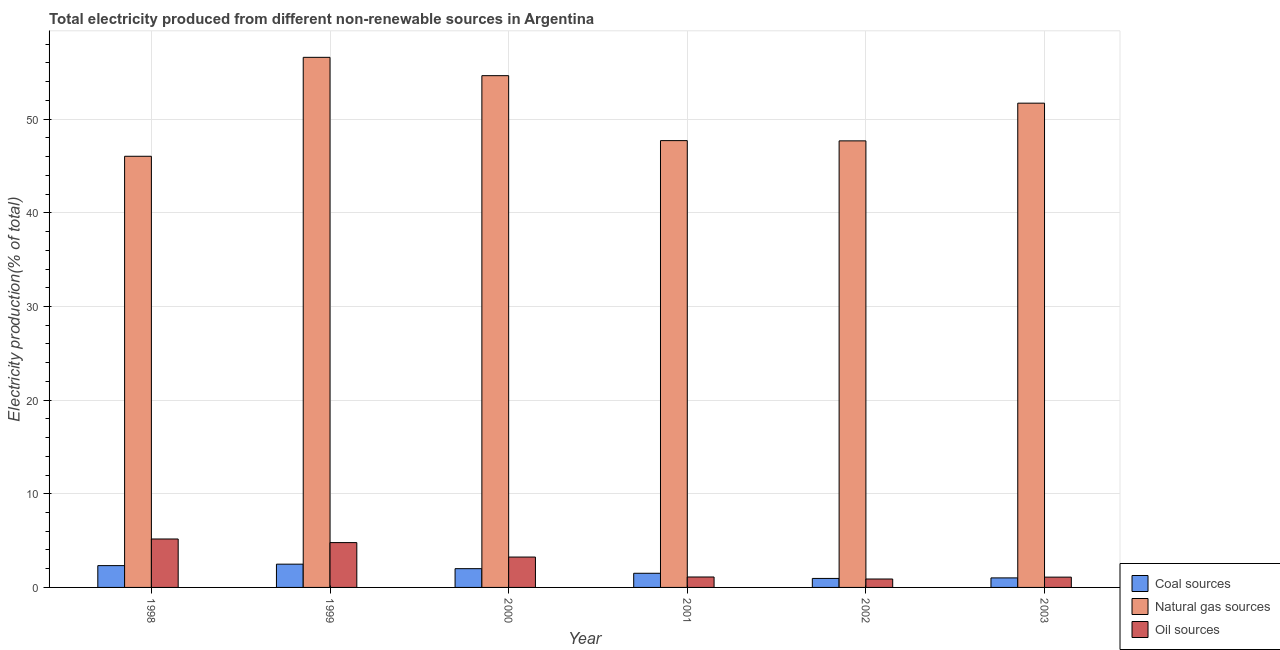Are the number of bars on each tick of the X-axis equal?
Offer a very short reply. Yes. How many bars are there on the 4th tick from the right?
Provide a short and direct response. 3. What is the label of the 2nd group of bars from the left?
Provide a succinct answer. 1999. What is the percentage of electricity produced by oil sources in 2001?
Offer a very short reply. 1.11. Across all years, what is the maximum percentage of electricity produced by coal?
Keep it short and to the point. 2.48. Across all years, what is the minimum percentage of electricity produced by natural gas?
Keep it short and to the point. 46.04. In which year was the percentage of electricity produced by coal maximum?
Your response must be concise. 1999. What is the total percentage of electricity produced by natural gas in the graph?
Offer a terse response. 304.4. What is the difference between the percentage of electricity produced by oil sources in 1999 and that in 2003?
Give a very brief answer. 3.69. What is the difference between the percentage of electricity produced by coal in 2003 and the percentage of electricity produced by natural gas in 1998?
Your response must be concise. -1.31. What is the average percentage of electricity produced by coal per year?
Your answer should be very brief. 1.72. What is the ratio of the percentage of electricity produced by natural gas in 2000 to that in 2002?
Your answer should be compact. 1.15. Is the percentage of electricity produced by coal in 1998 less than that in 2000?
Provide a short and direct response. No. Is the difference between the percentage of electricity produced by oil sources in 2000 and 2003 greater than the difference between the percentage of electricity produced by coal in 2000 and 2003?
Your answer should be very brief. No. What is the difference between the highest and the second highest percentage of electricity produced by oil sources?
Provide a succinct answer. 0.39. What is the difference between the highest and the lowest percentage of electricity produced by oil sources?
Your answer should be compact. 4.27. What does the 2nd bar from the left in 2001 represents?
Give a very brief answer. Natural gas sources. What does the 3rd bar from the right in 2003 represents?
Make the answer very short. Coal sources. How many bars are there?
Give a very brief answer. 18. Are all the bars in the graph horizontal?
Your answer should be compact. No. What is the difference between two consecutive major ticks on the Y-axis?
Offer a terse response. 10. Where does the legend appear in the graph?
Make the answer very short. Bottom right. What is the title of the graph?
Make the answer very short. Total electricity produced from different non-renewable sources in Argentina. What is the Electricity production(% of total) in Coal sources in 1998?
Your response must be concise. 2.33. What is the Electricity production(% of total) in Natural gas sources in 1998?
Give a very brief answer. 46.04. What is the Electricity production(% of total) in Oil sources in 1998?
Make the answer very short. 5.17. What is the Electricity production(% of total) in Coal sources in 1999?
Your answer should be very brief. 2.48. What is the Electricity production(% of total) in Natural gas sources in 1999?
Make the answer very short. 56.6. What is the Electricity production(% of total) in Oil sources in 1999?
Give a very brief answer. 4.79. What is the Electricity production(% of total) in Coal sources in 2000?
Offer a terse response. 2. What is the Electricity production(% of total) of Natural gas sources in 2000?
Your response must be concise. 54.65. What is the Electricity production(% of total) of Oil sources in 2000?
Keep it short and to the point. 3.24. What is the Electricity production(% of total) of Coal sources in 2001?
Ensure brevity in your answer.  1.51. What is the Electricity production(% of total) of Natural gas sources in 2001?
Your answer should be very brief. 47.71. What is the Electricity production(% of total) of Oil sources in 2001?
Offer a terse response. 1.11. What is the Electricity production(% of total) in Coal sources in 2002?
Offer a very short reply. 0.96. What is the Electricity production(% of total) of Natural gas sources in 2002?
Provide a succinct answer. 47.68. What is the Electricity production(% of total) in Oil sources in 2002?
Provide a succinct answer. 0.9. What is the Electricity production(% of total) in Coal sources in 2003?
Make the answer very short. 1.02. What is the Electricity production(% of total) of Natural gas sources in 2003?
Offer a terse response. 51.71. What is the Electricity production(% of total) in Oil sources in 2003?
Provide a short and direct response. 1.1. Across all years, what is the maximum Electricity production(% of total) in Coal sources?
Make the answer very short. 2.48. Across all years, what is the maximum Electricity production(% of total) in Natural gas sources?
Your answer should be very brief. 56.6. Across all years, what is the maximum Electricity production(% of total) of Oil sources?
Make the answer very short. 5.17. Across all years, what is the minimum Electricity production(% of total) of Coal sources?
Your response must be concise. 0.96. Across all years, what is the minimum Electricity production(% of total) of Natural gas sources?
Ensure brevity in your answer.  46.04. Across all years, what is the minimum Electricity production(% of total) of Oil sources?
Provide a short and direct response. 0.9. What is the total Electricity production(% of total) of Coal sources in the graph?
Your response must be concise. 10.31. What is the total Electricity production(% of total) of Natural gas sources in the graph?
Your answer should be very brief. 304.4. What is the total Electricity production(% of total) of Oil sources in the graph?
Offer a terse response. 16.31. What is the difference between the Electricity production(% of total) in Coal sources in 1998 and that in 1999?
Give a very brief answer. -0.16. What is the difference between the Electricity production(% of total) of Natural gas sources in 1998 and that in 1999?
Offer a very short reply. -10.56. What is the difference between the Electricity production(% of total) of Oil sources in 1998 and that in 1999?
Offer a very short reply. 0.39. What is the difference between the Electricity production(% of total) in Coal sources in 1998 and that in 2000?
Give a very brief answer. 0.32. What is the difference between the Electricity production(% of total) of Natural gas sources in 1998 and that in 2000?
Keep it short and to the point. -8.61. What is the difference between the Electricity production(% of total) of Oil sources in 1998 and that in 2000?
Make the answer very short. 1.93. What is the difference between the Electricity production(% of total) of Coal sources in 1998 and that in 2001?
Keep it short and to the point. 0.82. What is the difference between the Electricity production(% of total) in Natural gas sources in 1998 and that in 2001?
Keep it short and to the point. -1.67. What is the difference between the Electricity production(% of total) in Oil sources in 1998 and that in 2001?
Provide a short and direct response. 4.06. What is the difference between the Electricity production(% of total) in Coal sources in 1998 and that in 2002?
Make the answer very short. 1.37. What is the difference between the Electricity production(% of total) of Natural gas sources in 1998 and that in 2002?
Provide a short and direct response. -1.64. What is the difference between the Electricity production(% of total) in Oil sources in 1998 and that in 2002?
Your response must be concise. 4.27. What is the difference between the Electricity production(% of total) in Coal sources in 1998 and that in 2003?
Your answer should be very brief. 1.31. What is the difference between the Electricity production(% of total) of Natural gas sources in 1998 and that in 2003?
Ensure brevity in your answer.  -5.67. What is the difference between the Electricity production(% of total) of Oil sources in 1998 and that in 2003?
Make the answer very short. 4.07. What is the difference between the Electricity production(% of total) of Coal sources in 1999 and that in 2000?
Keep it short and to the point. 0.48. What is the difference between the Electricity production(% of total) of Natural gas sources in 1999 and that in 2000?
Make the answer very short. 1.96. What is the difference between the Electricity production(% of total) of Oil sources in 1999 and that in 2000?
Keep it short and to the point. 1.54. What is the difference between the Electricity production(% of total) in Coal sources in 1999 and that in 2001?
Ensure brevity in your answer.  0.97. What is the difference between the Electricity production(% of total) of Natural gas sources in 1999 and that in 2001?
Offer a terse response. 8.89. What is the difference between the Electricity production(% of total) in Oil sources in 1999 and that in 2001?
Make the answer very short. 3.67. What is the difference between the Electricity production(% of total) in Coal sources in 1999 and that in 2002?
Offer a very short reply. 1.52. What is the difference between the Electricity production(% of total) in Natural gas sources in 1999 and that in 2002?
Keep it short and to the point. 8.92. What is the difference between the Electricity production(% of total) of Oil sources in 1999 and that in 2002?
Your response must be concise. 3.89. What is the difference between the Electricity production(% of total) in Coal sources in 1999 and that in 2003?
Offer a terse response. 1.47. What is the difference between the Electricity production(% of total) in Natural gas sources in 1999 and that in 2003?
Your response must be concise. 4.89. What is the difference between the Electricity production(% of total) of Oil sources in 1999 and that in 2003?
Keep it short and to the point. 3.69. What is the difference between the Electricity production(% of total) in Coal sources in 2000 and that in 2001?
Provide a succinct answer. 0.49. What is the difference between the Electricity production(% of total) in Natural gas sources in 2000 and that in 2001?
Your answer should be compact. 6.94. What is the difference between the Electricity production(% of total) of Oil sources in 2000 and that in 2001?
Offer a terse response. 2.13. What is the difference between the Electricity production(% of total) of Coal sources in 2000 and that in 2002?
Make the answer very short. 1.04. What is the difference between the Electricity production(% of total) of Natural gas sources in 2000 and that in 2002?
Offer a terse response. 6.96. What is the difference between the Electricity production(% of total) in Oil sources in 2000 and that in 2002?
Provide a succinct answer. 2.34. What is the difference between the Electricity production(% of total) of Natural gas sources in 2000 and that in 2003?
Offer a terse response. 2.94. What is the difference between the Electricity production(% of total) in Oil sources in 2000 and that in 2003?
Offer a very short reply. 2.14. What is the difference between the Electricity production(% of total) of Coal sources in 2001 and that in 2002?
Provide a short and direct response. 0.55. What is the difference between the Electricity production(% of total) in Natural gas sources in 2001 and that in 2002?
Provide a succinct answer. 0.03. What is the difference between the Electricity production(% of total) in Oil sources in 2001 and that in 2002?
Keep it short and to the point. 0.22. What is the difference between the Electricity production(% of total) of Coal sources in 2001 and that in 2003?
Provide a succinct answer. 0.49. What is the difference between the Electricity production(% of total) of Natural gas sources in 2001 and that in 2003?
Make the answer very short. -4. What is the difference between the Electricity production(% of total) in Oil sources in 2001 and that in 2003?
Ensure brevity in your answer.  0.02. What is the difference between the Electricity production(% of total) of Coal sources in 2002 and that in 2003?
Ensure brevity in your answer.  -0.06. What is the difference between the Electricity production(% of total) of Natural gas sources in 2002 and that in 2003?
Your answer should be compact. -4.03. What is the difference between the Electricity production(% of total) of Oil sources in 2002 and that in 2003?
Your answer should be very brief. -0.2. What is the difference between the Electricity production(% of total) of Coal sources in 1998 and the Electricity production(% of total) of Natural gas sources in 1999?
Offer a terse response. -54.28. What is the difference between the Electricity production(% of total) in Coal sources in 1998 and the Electricity production(% of total) in Oil sources in 1999?
Ensure brevity in your answer.  -2.46. What is the difference between the Electricity production(% of total) in Natural gas sources in 1998 and the Electricity production(% of total) in Oil sources in 1999?
Provide a succinct answer. 41.25. What is the difference between the Electricity production(% of total) of Coal sources in 1998 and the Electricity production(% of total) of Natural gas sources in 2000?
Ensure brevity in your answer.  -52.32. What is the difference between the Electricity production(% of total) in Coal sources in 1998 and the Electricity production(% of total) in Oil sources in 2000?
Provide a short and direct response. -0.91. What is the difference between the Electricity production(% of total) in Natural gas sources in 1998 and the Electricity production(% of total) in Oil sources in 2000?
Your answer should be very brief. 42.8. What is the difference between the Electricity production(% of total) in Coal sources in 1998 and the Electricity production(% of total) in Natural gas sources in 2001?
Make the answer very short. -45.38. What is the difference between the Electricity production(% of total) of Coal sources in 1998 and the Electricity production(% of total) of Oil sources in 2001?
Your answer should be very brief. 1.21. What is the difference between the Electricity production(% of total) in Natural gas sources in 1998 and the Electricity production(% of total) in Oil sources in 2001?
Provide a succinct answer. 44.93. What is the difference between the Electricity production(% of total) of Coal sources in 1998 and the Electricity production(% of total) of Natural gas sources in 2002?
Offer a terse response. -45.36. What is the difference between the Electricity production(% of total) in Coal sources in 1998 and the Electricity production(% of total) in Oil sources in 2002?
Provide a succinct answer. 1.43. What is the difference between the Electricity production(% of total) of Natural gas sources in 1998 and the Electricity production(% of total) of Oil sources in 2002?
Provide a short and direct response. 45.14. What is the difference between the Electricity production(% of total) in Coal sources in 1998 and the Electricity production(% of total) in Natural gas sources in 2003?
Offer a very short reply. -49.38. What is the difference between the Electricity production(% of total) in Coal sources in 1998 and the Electricity production(% of total) in Oil sources in 2003?
Provide a short and direct response. 1.23. What is the difference between the Electricity production(% of total) in Natural gas sources in 1998 and the Electricity production(% of total) in Oil sources in 2003?
Provide a succinct answer. 44.94. What is the difference between the Electricity production(% of total) of Coal sources in 1999 and the Electricity production(% of total) of Natural gas sources in 2000?
Make the answer very short. -52.16. What is the difference between the Electricity production(% of total) of Coal sources in 1999 and the Electricity production(% of total) of Oil sources in 2000?
Your response must be concise. -0.76. What is the difference between the Electricity production(% of total) in Natural gas sources in 1999 and the Electricity production(% of total) in Oil sources in 2000?
Provide a short and direct response. 53.36. What is the difference between the Electricity production(% of total) in Coal sources in 1999 and the Electricity production(% of total) in Natural gas sources in 2001?
Make the answer very short. -45.23. What is the difference between the Electricity production(% of total) in Coal sources in 1999 and the Electricity production(% of total) in Oil sources in 2001?
Ensure brevity in your answer.  1.37. What is the difference between the Electricity production(% of total) in Natural gas sources in 1999 and the Electricity production(% of total) in Oil sources in 2001?
Your answer should be very brief. 55.49. What is the difference between the Electricity production(% of total) in Coal sources in 1999 and the Electricity production(% of total) in Natural gas sources in 2002?
Offer a very short reply. -45.2. What is the difference between the Electricity production(% of total) of Coal sources in 1999 and the Electricity production(% of total) of Oil sources in 2002?
Keep it short and to the point. 1.59. What is the difference between the Electricity production(% of total) in Natural gas sources in 1999 and the Electricity production(% of total) in Oil sources in 2002?
Give a very brief answer. 55.71. What is the difference between the Electricity production(% of total) in Coal sources in 1999 and the Electricity production(% of total) in Natural gas sources in 2003?
Ensure brevity in your answer.  -49.23. What is the difference between the Electricity production(% of total) in Coal sources in 1999 and the Electricity production(% of total) in Oil sources in 2003?
Provide a succinct answer. 1.39. What is the difference between the Electricity production(% of total) of Natural gas sources in 1999 and the Electricity production(% of total) of Oil sources in 2003?
Offer a terse response. 55.51. What is the difference between the Electricity production(% of total) of Coal sources in 2000 and the Electricity production(% of total) of Natural gas sources in 2001?
Ensure brevity in your answer.  -45.71. What is the difference between the Electricity production(% of total) in Coal sources in 2000 and the Electricity production(% of total) in Oil sources in 2001?
Your response must be concise. 0.89. What is the difference between the Electricity production(% of total) of Natural gas sources in 2000 and the Electricity production(% of total) of Oil sources in 2001?
Offer a very short reply. 53.53. What is the difference between the Electricity production(% of total) in Coal sources in 2000 and the Electricity production(% of total) in Natural gas sources in 2002?
Offer a very short reply. -45.68. What is the difference between the Electricity production(% of total) in Coal sources in 2000 and the Electricity production(% of total) in Oil sources in 2002?
Your response must be concise. 1.1. What is the difference between the Electricity production(% of total) of Natural gas sources in 2000 and the Electricity production(% of total) of Oil sources in 2002?
Your answer should be very brief. 53.75. What is the difference between the Electricity production(% of total) in Coal sources in 2000 and the Electricity production(% of total) in Natural gas sources in 2003?
Provide a short and direct response. -49.71. What is the difference between the Electricity production(% of total) of Coal sources in 2000 and the Electricity production(% of total) of Oil sources in 2003?
Offer a terse response. 0.9. What is the difference between the Electricity production(% of total) of Natural gas sources in 2000 and the Electricity production(% of total) of Oil sources in 2003?
Make the answer very short. 53.55. What is the difference between the Electricity production(% of total) of Coal sources in 2001 and the Electricity production(% of total) of Natural gas sources in 2002?
Provide a succinct answer. -46.17. What is the difference between the Electricity production(% of total) of Coal sources in 2001 and the Electricity production(% of total) of Oil sources in 2002?
Your answer should be very brief. 0.61. What is the difference between the Electricity production(% of total) in Natural gas sources in 2001 and the Electricity production(% of total) in Oil sources in 2002?
Provide a succinct answer. 46.81. What is the difference between the Electricity production(% of total) in Coal sources in 2001 and the Electricity production(% of total) in Natural gas sources in 2003?
Keep it short and to the point. -50.2. What is the difference between the Electricity production(% of total) of Coal sources in 2001 and the Electricity production(% of total) of Oil sources in 2003?
Ensure brevity in your answer.  0.41. What is the difference between the Electricity production(% of total) in Natural gas sources in 2001 and the Electricity production(% of total) in Oil sources in 2003?
Make the answer very short. 46.61. What is the difference between the Electricity production(% of total) of Coal sources in 2002 and the Electricity production(% of total) of Natural gas sources in 2003?
Your answer should be compact. -50.75. What is the difference between the Electricity production(% of total) in Coal sources in 2002 and the Electricity production(% of total) in Oil sources in 2003?
Ensure brevity in your answer.  -0.14. What is the difference between the Electricity production(% of total) in Natural gas sources in 2002 and the Electricity production(% of total) in Oil sources in 2003?
Your answer should be very brief. 46.59. What is the average Electricity production(% of total) of Coal sources per year?
Your answer should be compact. 1.72. What is the average Electricity production(% of total) in Natural gas sources per year?
Provide a short and direct response. 50.73. What is the average Electricity production(% of total) in Oil sources per year?
Offer a terse response. 2.72. In the year 1998, what is the difference between the Electricity production(% of total) in Coal sources and Electricity production(% of total) in Natural gas sources?
Your answer should be very brief. -43.71. In the year 1998, what is the difference between the Electricity production(% of total) of Coal sources and Electricity production(% of total) of Oil sources?
Give a very brief answer. -2.84. In the year 1998, what is the difference between the Electricity production(% of total) of Natural gas sources and Electricity production(% of total) of Oil sources?
Provide a succinct answer. 40.87. In the year 1999, what is the difference between the Electricity production(% of total) of Coal sources and Electricity production(% of total) of Natural gas sources?
Your answer should be very brief. -54.12. In the year 1999, what is the difference between the Electricity production(% of total) of Coal sources and Electricity production(% of total) of Oil sources?
Offer a terse response. -2.3. In the year 1999, what is the difference between the Electricity production(% of total) of Natural gas sources and Electricity production(% of total) of Oil sources?
Provide a short and direct response. 51.82. In the year 2000, what is the difference between the Electricity production(% of total) of Coal sources and Electricity production(% of total) of Natural gas sources?
Provide a succinct answer. -52.64. In the year 2000, what is the difference between the Electricity production(% of total) of Coal sources and Electricity production(% of total) of Oil sources?
Ensure brevity in your answer.  -1.24. In the year 2000, what is the difference between the Electricity production(% of total) in Natural gas sources and Electricity production(% of total) in Oil sources?
Your answer should be compact. 51.4. In the year 2001, what is the difference between the Electricity production(% of total) in Coal sources and Electricity production(% of total) in Natural gas sources?
Offer a terse response. -46.2. In the year 2001, what is the difference between the Electricity production(% of total) in Coal sources and Electricity production(% of total) in Oil sources?
Offer a very short reply. 0.4. In the year 2001, what is the difference between the Electricity production(% of total) of Natural gas sources and Electricity production(% of total) of Oil sources?
Offer a terse response. 46.6. In the year 2002, what is the difference between the Electricity production(% of total) in Coal sources and Electricity production(% of total) in Natural gas sources?
Ensure brevity in your answer.  -46.72. In the year 2002, what is the difference between the Electricity production(% of total) in Coal sources and Electricity production(% of total) in Oil sources?
Ensure brevity in your answer.  0.06. In the year 2002, what is the difference between the Electricity production(% of total) of Natural gas sources and Electricity production(% of total) of Oil sources?
Your answer should be very brief. 46.79. In the year 2003, what is the difference between the Electricity production(% of total) of Coal sources and Electricity production(% of total) of Natural gas sources?
Your response must be concise. -50.69. In the year 2003, what is the difference between the Electricity production(% of total) in Coal sources and Electricity production(% of total) in Oil sources?
Make the answer very short. -0.08. In the year 2003, what is the difference between the Electricity production(% of total) in Natural gas sources and Electricity production(% of total) in Oil sources?
Ensure brevity in your answer.  50.61. What is the ratio of the Electricity production(% of total) in Coal sources in 1998 to that in 1999?
Provide a short and direct response. 0.94. What is the ratio of the Electricity production(% of total) of Natural gas sources in 1998 to that in 1999?
Offer a terse response. 0.81. What is the ratio of the Electricity production(% of total) of Oil sources in 1998 to that in 1999?
Ensure brevity in your answer.  1.08. What is the ratio of the Electricity production(% of total) in Coal sources in 1998 to that in 2000?
Provide a succinct answer. 1.16. What is the ratio of the Electricity production(% of total) in Natural gas sources in 1998 to that in 2000?
Provide a short and direct response. 0.84. What is the ratio of the Electricity production(% of total) in Oil sources in 1998 to that in 2000?
Give a very brief answer. 1.6. What is the ratio of the Electricity production(% of total) in Coal sources in 1998 to that in 2001?
Give a very brief answer. 1.54. What is the ratio of the Electricity production(% of total) of Oil sources in 1998 to that in 2001?
Your response must be concise. 4.64. What is the ratio of the Electricity production(% of total) of Coal sources in 1998 to that in 2002?
Offer a very short reply. 2.42. What is the ratio of the Electricity production(% of total) in Natural gas sources in 1998 to that in 2002?
Provide a succinct answer. 0.97. What is the ratio of the Electricity production(% of total) of Oil sources in 1998 to that in 2002?
Provide a succinct answer. 5.75. What is the ratio of the Electricity production(% of total) in Coal sources in 1998 to that in 2003?
Ensure brevity in your answer.  2.29. What is the ratio of the Electricity production(% of total) in Natural gas sources in 1998 to that in 2003?
Your answer should be compact. 0.89. What is the ratio of the Electricity production(% of total) of Oil sources in 1998 to that in 2003?
Offer a terse response. 4.71. What is the ratio of the Electricity production(% of total) of Coal sources in 1999 to that in 2000?
Provide a short and direct response. 1.24. What is the ratio of the Electricity production(% of total) of Natural gas sources in 1999 to that in 2000?
Provide a succinct answer. 1.04. What is the ratio of the Electricity production(% of total) of Oil sources in 1999 to that in 2000?
Your response must be concise. 1.48. What is the ratio of the Electricity production(% of total) of Coal sources in 1999 to that in 2001?
Your response must be concise. 1.64. What is the ratio of the Electricity production(% of total) of Natural gas sources in 1999 to that in 2001?
Offer a terse response. 1.19. What is the ratio of the Electricity production(% of total) of Oil sources in 1999 to that in 2001?
Offer a very short reply. 4.3. What is the ratio of the Electricity production(% of total) of Coal sources in 1999 to that in 2002?
Your answer should be compact. 2.59. What is the ratio of the Electricity production(% of total) of Natural gas sources in 1999 to that in 2002?
Offer a terse response. 1.19. What is the ratio of the Electricity production(% of total) in Oil sources in 1999 to that in 2002?
Your response must be concise. 5.33. What is the ratio of the Electricity production(% of total) of Coal sources in 1999 to that in 2003?
Make the answer very short. 2.44. What is the ratio of the Electricity production(% of total) of Natural gas sources in 1999 to that in 2003?
Provide a succinct answer. 1.09. What is the ratio of the Electricity production(% of total) in Oil sources in 1999 to that in 2003?
Your answer should be very brief. 4.36. What is the ratio of the Electricity production(% of total) in Coal sources in 2000 to that in 2001?
Keep it short and to the point. 1.33. What is the ratio of the Electricity production(% of total) of Natural gas sources in 2000 to that in 2001?
Keep it short and to the point. 1.15. What is the ratio of the Electricity production(% of total) in Oil sources in 2000 to that in 2001?
Offer a terse response. 2.91. What is the ratio of the Electricity production(% of total) of Coal sources in 2000 to that in 2002?
Your response must be concise. 2.09. What is the ratio of the Electricity production(% of total) in Natural gas sources in 2000 to that in 2002?
Offer a terse response. 1.15. What is the ratio of the Electricity production(% of total) in Oil sources in 2000 to that in 2002?
Provide a short and direct response. 3.61. What is the ratio of the Electricity production(% of total) of Coal sources in 2000 to that in 2003?
Provide a short and direct response. 1.97. What is the ratio of the Electricity production(% of total) in Natural gas sources in 2000 to that in 2003?
Keep it short and to the point. 1.06. What is the ratio of the Electricity production(% of total) of Oil sources in 2000 to that in 2003?
Make the answer very short. 2.95. What is the ratio of the Electricity production(% of total) of Coal sources in 2001 to that in 2002?
Your response must be concise. 1.57. What is the ratio of the Electricity production(% of total) in Oil sources in 2001 to that in 2002?
Your answer should be compact. 1.24. What is the ratio of the Electricity production(% of total) in Coal sources in 2001 to that in 2003?
Your response must be concise. 1.48. What is the ratio of the Electricity production(% of total) in Natural gas sources in 2001 to that in 2003?
Keep it short and to the point. 0.92. What is the ratio of the Electricity production(% of total) of Oil sources in 2001 to that in 2003?
Offer a very short reply. 1.01. What is the ratio of the Electricity production(% of total) of Coal sources in 2002 to that in 2003?
Give a very brief answer. 0.94. What is the ratio of the Electricity production(% of total) of Natural gas sources in 2002 to that in 2003?
Give a very brief answer. 0.92. What is the ratio of the Electricity production(% of total) in Oil sources in 2002 to that in 2003?
Offer a terse response. 0.82. What is the difference between the highest and the second highest Electricity production(% of total) in Coal sources?
Provide a short and direct response. 0.16. What is the difference between the highest and the second highest Electricity production(% of total) of Natural gas sources?
Your answer should be very brief. 1.96. What is the difference between the highest and the second highest Electricity production(% of total) of Oil sources?
Provide a short and direct response. 0.39. What is the difference between the highest and the lowest Electricity production(% of total) in Coal sources?
Offer a very short reply. 1.52. What is the difference between the highest and the lowest Electricity production(% of total) of Natural gas sources?
Give a very brief answer. 10.56. What is the difference between the highest and the lowest Electricity production(% of total) in Oil sources?
Give a very brief answer. 4.27. 